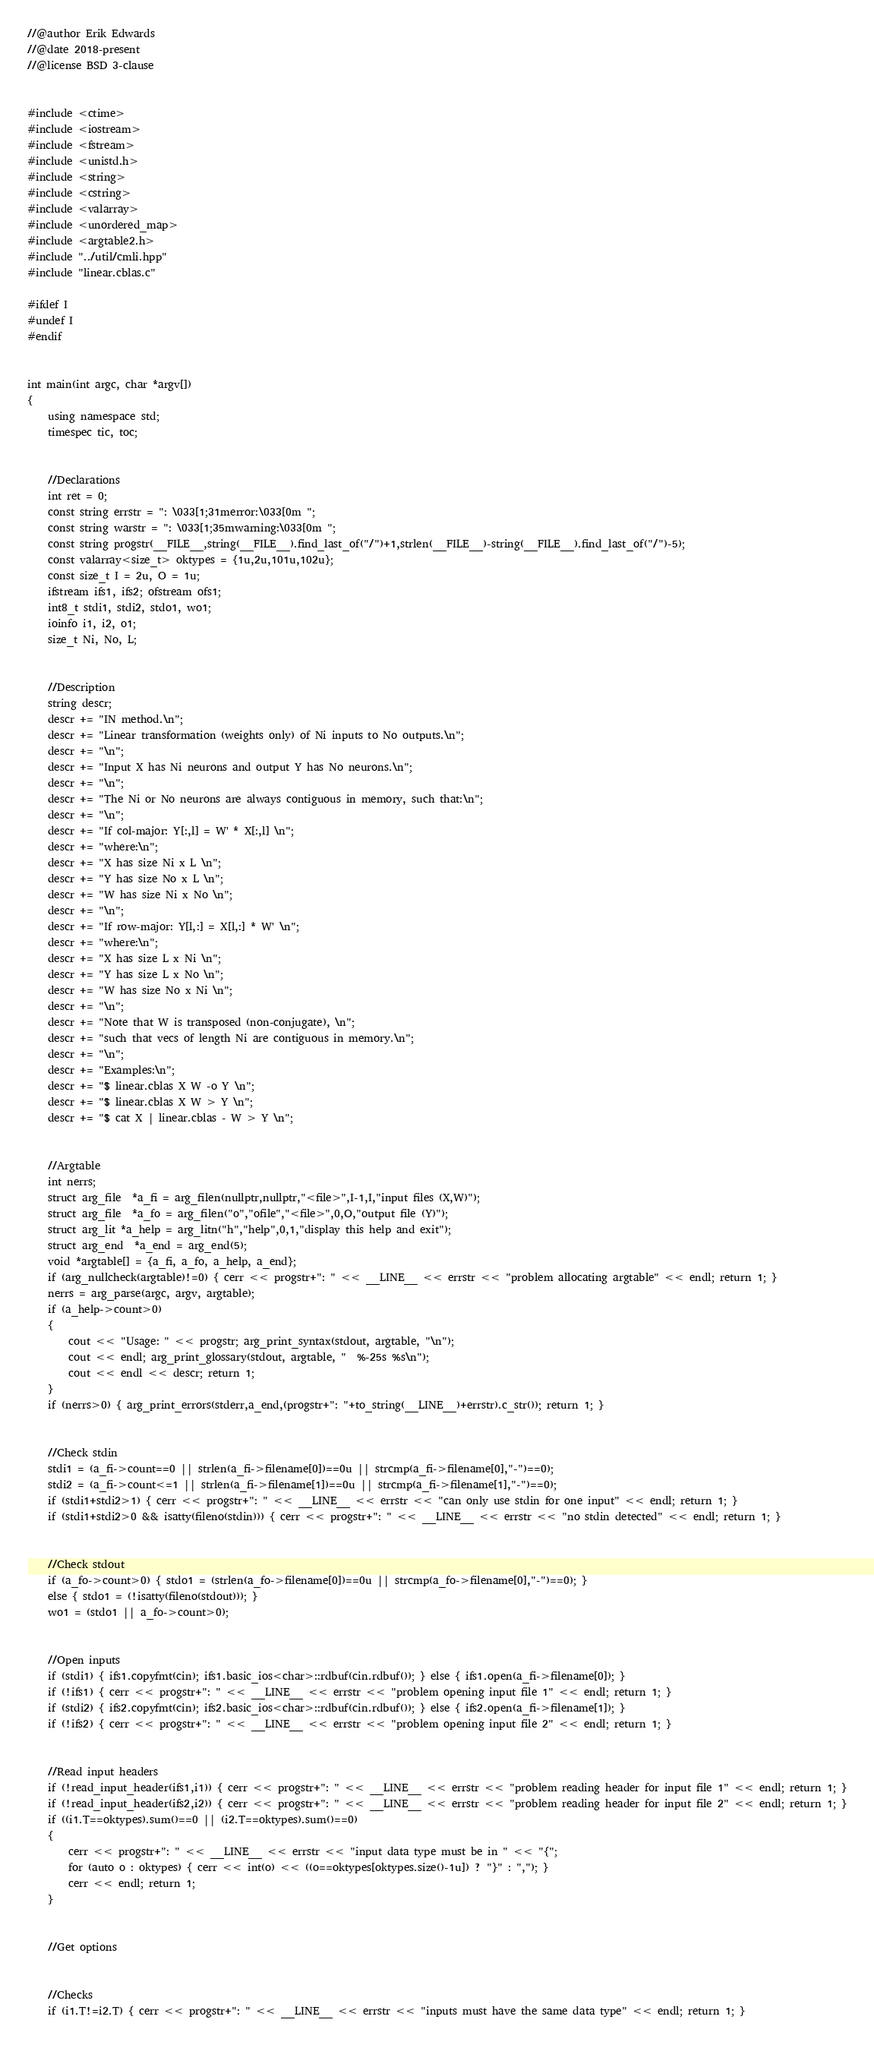Convert code to text. <code><loc_0><loc_0><loc_500><loc_500><_C++_>//@author Erik Edwards
//@date 2018-present
//@license BSD 3-clause


#include <ctime>
#include <iostream>
#include <fstream>
#include <unistd.h>
#include <string>
#include <cstring>
#include <valarray>
#include <unordered_map>
#include <argtable2.h>
#include "../util/cmli.hpp"
#include "linear.cblas.c"

#ifdef I
#undef I
#endif


int main(int argc, char *argv[])
{
    using namespace std;
    timespec tic, toc;


    //Declarations
    int ret = 0;
    const string errstr = ": \033[1;31merror:\033[0m ";
    const string warstr = ": \033[1;35mwarning:\033[0m ";
    const string progstr(__FILE__,string(__FILE__).find_last_of("/")+1,strlen(__FILE__)-string(__FILE__).find_last_of("/")-5);
    const valarray<size_t> oktypes = {1u,2u,101u,102u};
    const size_t I = 2u, O = 1u;
    ifstream ifs1, ifs2; ofstream ofs1;
    int8_t stdi1, stdi2, stdo1, wo1;
    ioinfo i1, i2, o1;
    size_t Ni, No, L;


    //Description
    string descr;
    descr += "IN method.\n";
    descr += "Linear transformation (weights only) of Ni inputs to No outputs.\n";
    descr += "\n";
    descr += "Input X has Ni neurons and output Y has No neurons.\n";
    descr += "\n";
    descr += "The Ni or No neurons are always contiguous in memory, such that:\n";
    descr += "\n";
    descr += "If col-major: Y[:,l] = W' * X[:,l] \n";
    descr += "where:\n";
    descr += "X has size Ni x L \n";
    descr += "Y has size No x L \n";
    descr += "W has size Ni x No \n";
    descr += "\n";
    descr += "If row-major: Y[l,:] = X[l,:] * W' \n";
    descr += "where:\n";
    descr += "X has size L x Ni \n";
    descr += "Y has size L x No \n";
    descr += "W has size No x Ni \n";
    descr += "\n";
    descr += "Note that W is transposed (non-conjugate), \n";
    descr += "such that vecs of length Ni are contiguous in memory.\n";
    descr += "\n";
    descr += "Examples:\n";
    descr += "$ linear.cblas X W -o Y \n";
    descr += "$ linear.cblas X W > Y \n";
    descr += "$ cat X | linear.cblas - W > Y \n";


    //Argtable
    int nerrs;
    struct arg_file  *a_fi = arg_filen(nullptr,nullptr,"<file>",I-1,I,"input files (X,W)");
    struct arg_file  *a_fo = arg_filen("o","ofile","<file>",0,O,"output file (Y)");
    struct arg_lit *a_help = arg_litn("h","help",0,1,"display this help and exit");
    struct arg_end  *a_end = arg_end(5);
    void *argtable[] = {a_fi, a_fo, a_help, a_end};
    if (arg_nullcheck(argtable)!=0) { cerr << progstr+": " << __LINE__ << errstr << "problem allocating argtable" << endl; return 1; }
    nerrs = arg_parse(argc, argv, argtable);
    if (a_help->count>0)
    {
        cout << "Usage: " << progstr; arg_print_syntax(stdout, argtable, "\n");
        cout << endl; arg_print_glossary(stdout, argtable, "  %-25s %s\n");
        cout << endl << descr; return 1;
    }
    if (nerrs>0) { arg_print_errors(stderr,a_end,(progstr+": "+to_string(__LINE__)+errstr).c_str()); return 1; }


    //Check stdin
    stdi1 = (a_fi->count==0 || strlen(a_fi->filename[0])==0u || strcmp(a_fi->filename[0],"-")==0);
    stdi2 = (a_fi->count<=1 || strlen(a_fi->filename[1])==0u || strcmp(a_fi->filename[1],"-")==0);
    if (stdi1+stdi2>1) { cerr << progstr+": " << __LINE__ << errstr << "can only use stdin for one input" << endl; return 1; }
    if (stdi1+stdi2>0 && isatty(fileno(stdin))) { cerr << progstr+": " << __LINE__ << errstr << "no stdin detected" << endl; return 1; }


    //Check stdout
    if (a_fo->count>0) { stdo1 = (strlen(a_fo->filename[0])==0u || strcmp(a_fo->filename[0],"-")==0); }
    else { stdo1 = (!isatty(fileno(stdout))); }
    wo1 = (stdo1 || a_fo->count>0);


    //Open inputs
    if (stdi1) { ifs1.copyfmt(cin); ifs1.basic_ios<char>::rdbuf(cin.rdbuf()); } else { ifs1.open(a_fi->filename[0]); }
    if (!ifs1) { cerr << progstr+": " << __LINE__ << errstr << "problem opening input file 1" << endl; return 1; }
    if (stdi2) { ifs2.copyfmt(cin); ifs2.basic_ios<char>::rdbuf(cin.rdbuf()); } else { ifs2.open(a_fi->filename[1]); }
    if (!ifs2) { cerr << progstr+": " << __LINE__ << errstr << "problem opening input file 2" << endl; return 1; }


    //Read input headers
    if (!read_input_header(ifs1,i1)) { cerr << progstr+": " << __LINE__ << errstr << "problem reading header for input file 1" << endl; return 1; }
    if (!read_input_header(ifs2,i2)) { cerr << progstr+": " << __LINE__ << errstr << "problem reading header for input file 2" << endl; return 1; }
    if ((i1.T==oktypes).sum()==0 || (i2.T==oktypes).sum()==0)
    {
        cerr << progstr+": " << __LINE__ << errstr << "input data type must be in " << "{";
        for (auto o : oktypes) { cerr << int(o) << ((o==oktypes[oktypes.size()-1u]) ? "}" : ","); }
        cerr << endl; return 1;
    }


    //Get options


    //Checks
    if (i1.T!=i2.T) { cerr << progstr+": " << __LINE__ << errstr << "inputs must have the same data type" << endl; return 1; }</code> 